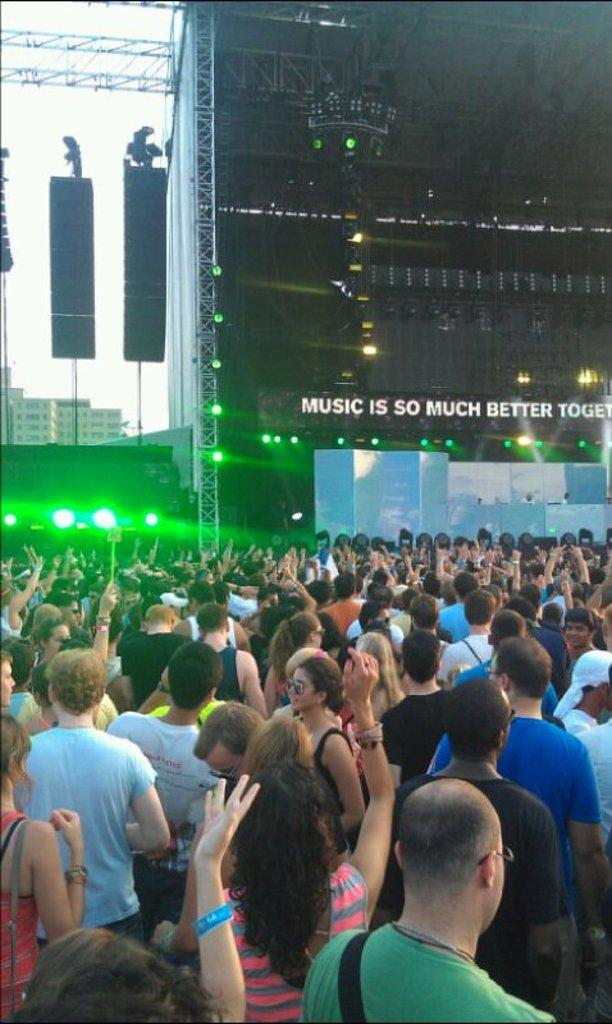What are the people in the image doing? There are groups of people standing on the path in the image. What is in front of the people? There is a stage in front of the people. What can be seen on the stage? The stage has lights. What is visible behind the stage? There are buildings behind the stage. What can be seen in the sky in the image? The sky is visible in the image. What type of wool is being used to create a fan in the image? There is no wool or fan present in the image. 